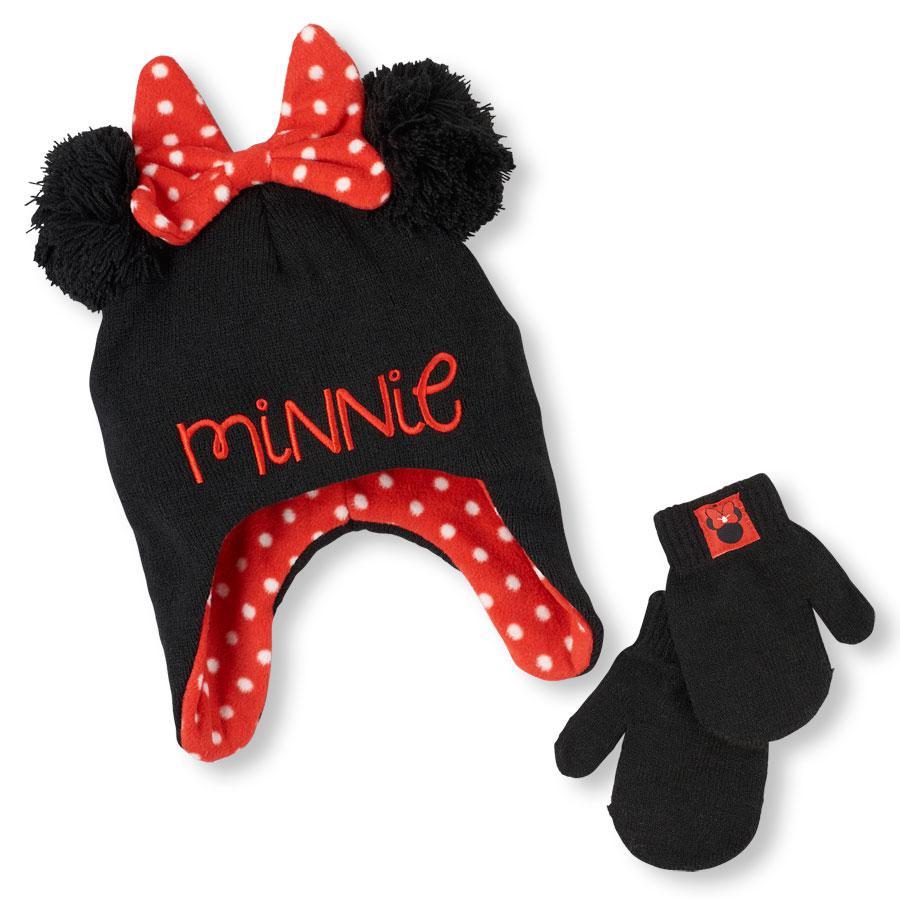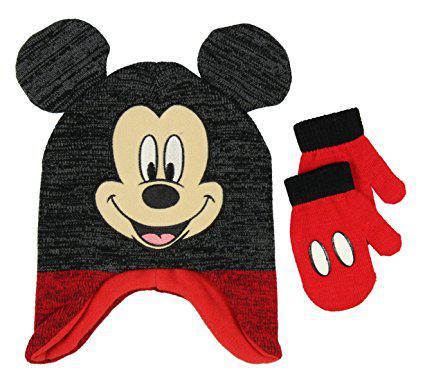The first image is the image on the left, the second image is the image on the right. Evaluate the accuracy of this statement regarding the images: "There is one black and red hat with black mouse ears and two white dots on it beside two red mittens with white Mickey Mouse logos and black cuffs in each image,.". Is it true? Answer yes or no. No. The first image is the image on the left, the second image is the image on the right. Assess this claim about the two images: "One hat is black and red with two white button dots and one pair of red and black gloves has a white Mickey Mouse shape on each glove.". Correct or not? Answer yes or no. No. 